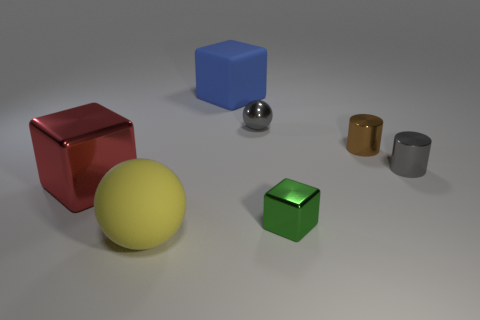Add 2 large red metal cubes. How many objects exist? 9 Subtract all balls. How many objects are left? 5 Subtract all tiny brown metallic cylinders. Subtract all small green metal objects. How many objects are left? 5 Add 3 gray cylinders. How many gray cylinders are left? 4 Add 2 small green metal objects. How many small green metal objects exist? 3 Subtract 0 gray cubes. How many objects are left? 7 